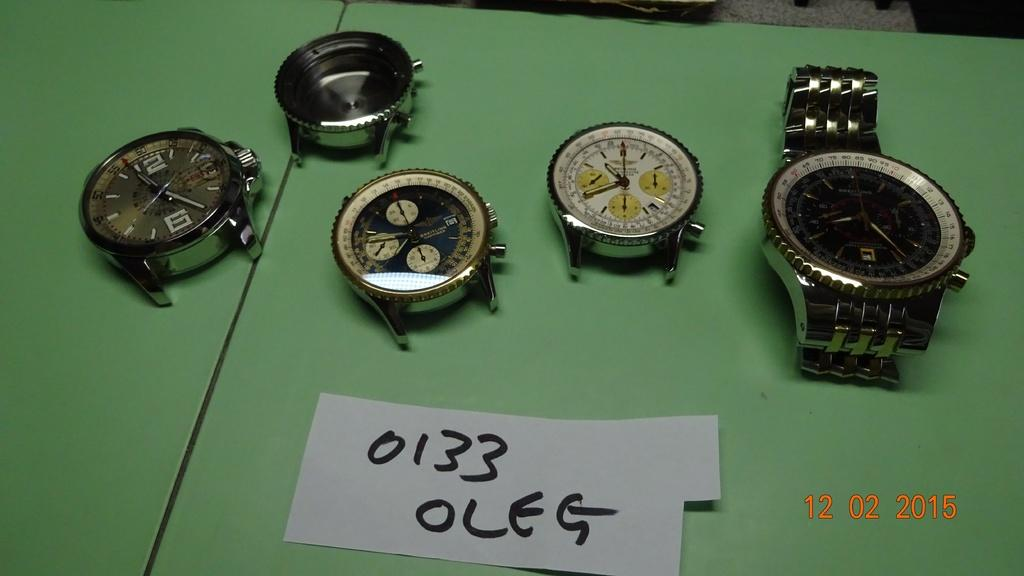<image>
Summarize the visual content of the image. Different watch faces and one watch are on a green board with the word oleg written beneath them. 